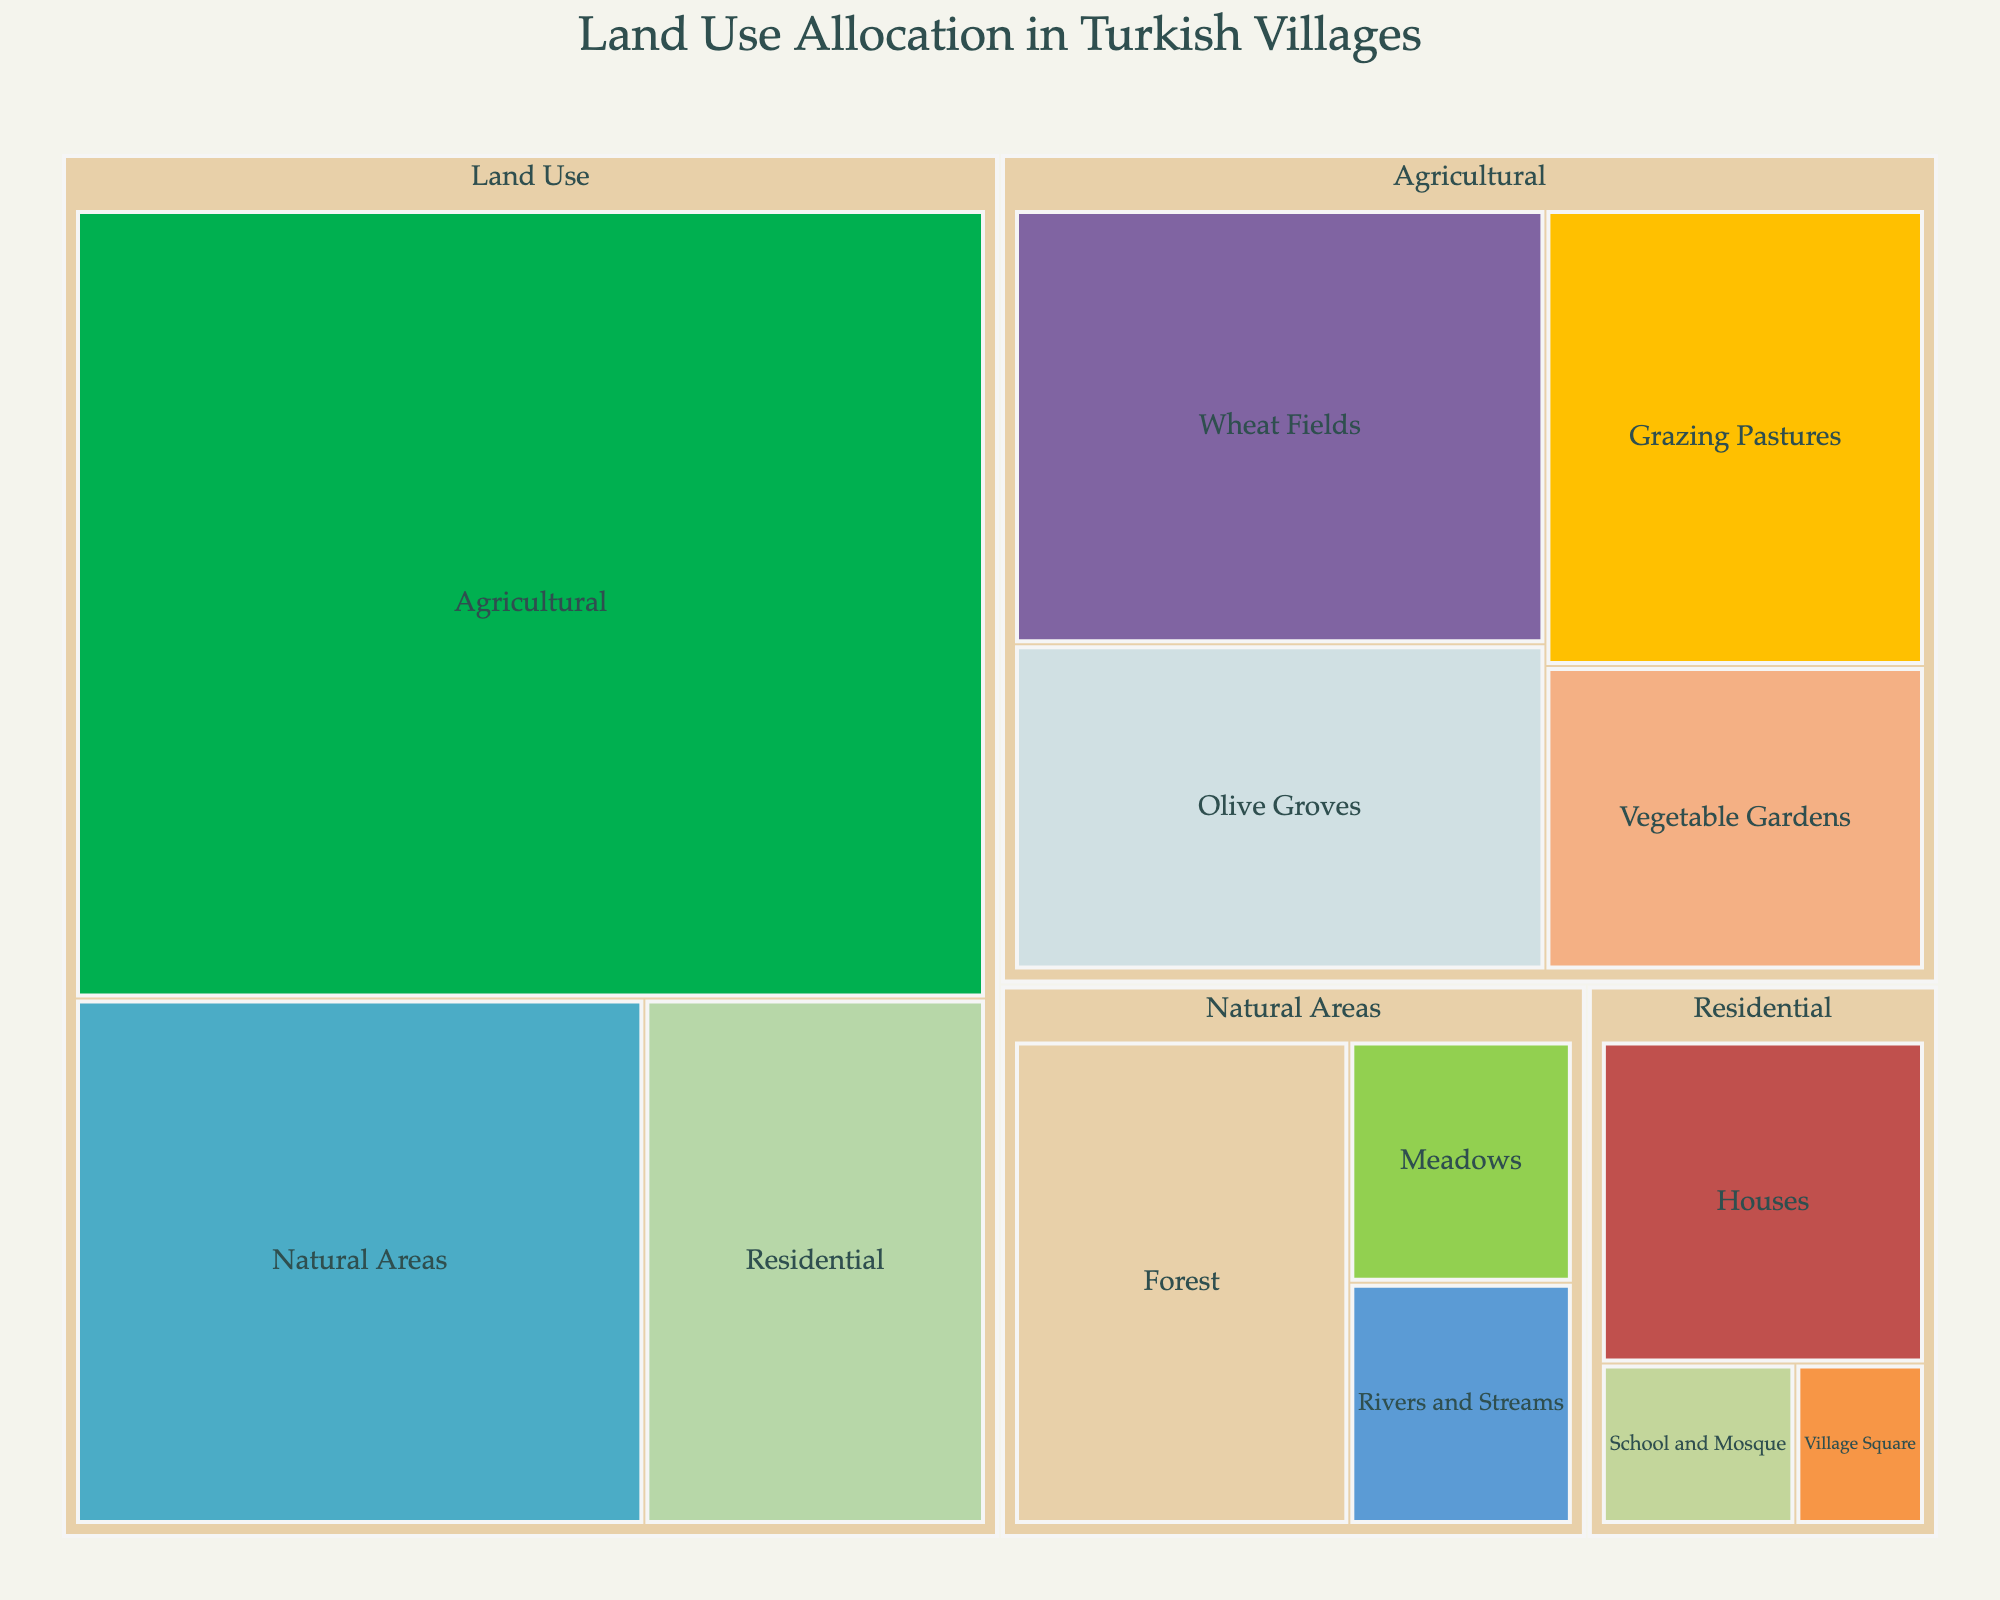what is the largest category of land use in Turkish villages according to the treemap? The treemap shows the land use in Turkish villages divided into various categories. The largest area within the treemap is "Agricultural," indicated by the largest segment representing 60%.
Answer: Agricultural Which specific subcategory occupies the most area within the "Agricultural" land use? Within the "Agricultural" category, the subcategories include Wheat Fields, Olive Groves, Vegetable Gardens, and Grazing Pastures. Among them, "Wheat Fields" has the largest value of 20%.
Answer: Wheat Fields How does the area allocated to "Natural Areas" compare to "Residential" areas? In the treemap, the natural areas occupy 25% of the land use, while residential areas occupy 15%. The natural area is larger by 10%.
Answer: Natural Areas are larger by 10% What is the combined land use percentage of all subcategories under "Residential"? The subcategories under "Residential" are Houses (10%), Village Square (2%), and School and Mosque (3%). Summing them up gives 10% + 2% + 3% = 15%.
Answer: 15% How many specific land use subcategories are shown in the treemap for all categories combined? The treemap breaks down the land use into specific subcategories: Residential (3), Agricultural (4), and Natural Areas (3). Summing these gives 3 + 4 + 3 = 10 subcategories.
Answer: 10 Which subcategory has a larger area: "Vegetable Gardens" or "Meadows"? Comparing their values, Vegetable Gardens have 10% and Meadows have 5%. Therefore, Vegetable Gardens occupy a larger area.
Answer: Vegetable Gardens What is the total percentage of the area used for the "School and Mosque" and "Village Square" combined? The subcategories "School and Mosque" and "Village Square" under Residential are 3% and 2% respectively. Adding them together gives 3% + 2% = 5%.
Answer: 5% Is "Forest" or "Rivers and Streams" occupying a larger area in the "Natural Areas"? Looking at the values in the "Natural Areas" category, Forest has 15% and Rivers and Streams have 5%. So, Forest occupies a larger area.
Answer: Forest Which subcategory occupies exactly 15% of land use? The subcategories with 15% values are Olive Groves, Grazing Pastures, and Forest.
Answer: Olive Groves, Grazing Pastures, and Forest What is the average land use percentage among "Vegetable Gardens," "Meadows," and "Rivers and Streams"? The subcategories are Vegetable Gardens (10%), Meadows (5%), and Rivers and Streams (5%). Summing them up gives 10 + 5 + 5 = 20. Dividing by 3 gives 20/3 ≈ 6.67%.
Answer: ≈ 6.67% 